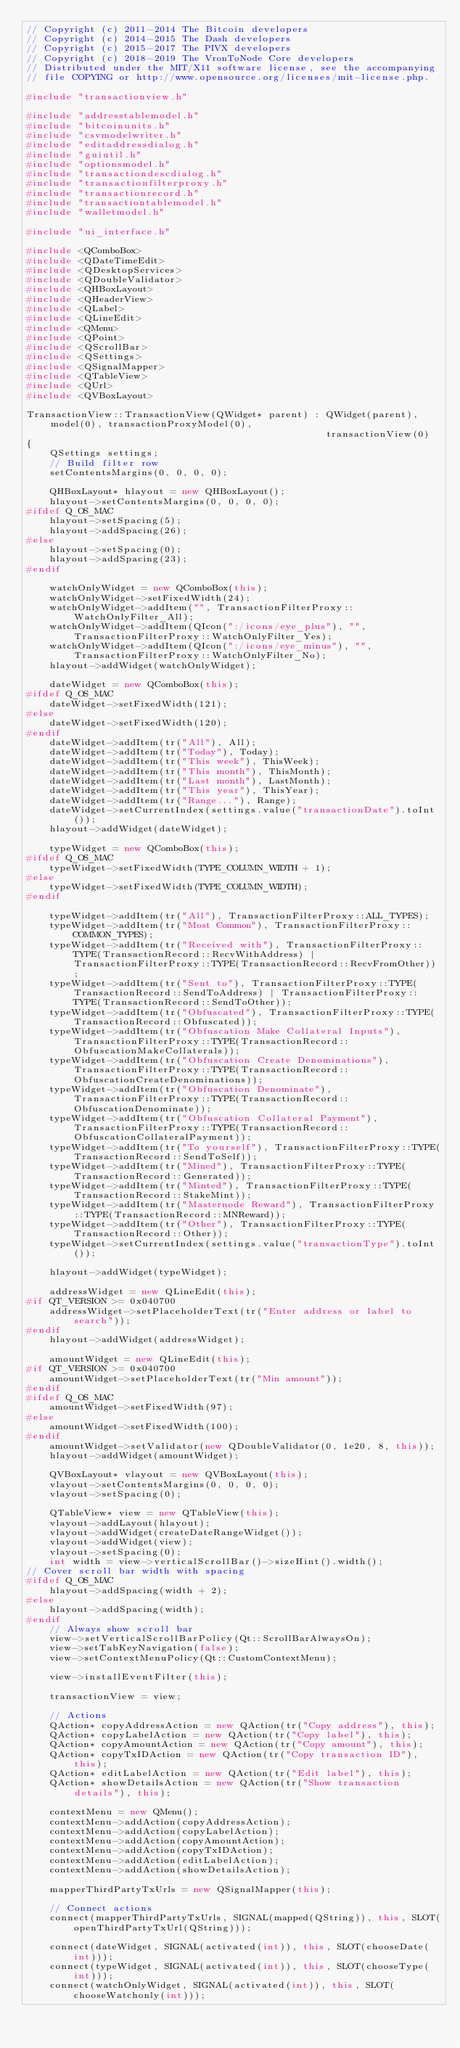Convert code to text. <code><loc_0><loc_0><loc_500><loc_500><_C++_>// Copyright (c) 2011-2014 The Bitcoin developers
// Copyright (c) 2014-2015 The Dash developers
// Copyright (c) 2015-2017 The PIVX developers
// Copyright (c) 2018-2019 The VronToNode Core developers
// Distributed under the MIT/X11 software license, see the accompanying
// file COPYING or http://www.opensource.org/licenses/mit-license.php.

#include "transactionview.h"

#include "addresstablemodel.h"
#include "bitcoinunits.h"
#include "csvmodelwriter.h"
#include "editaddressdialog.h"
#include "guiutil.h"
#include "optionsmodel.h"
#include "transactiondescdialog.h"
#include "transactionfilterproxy.h"
#include "transactionrecord.h"
#include "transactiontablemodel.h"
#include "walletmodel.h"

#include "ui_interface.h"

#include <QComboBox>
#include <QDateTimeEdit>
#include <QDesktopServices>
#include <QDoubleValidator>
#include <QHBoxLayout>
#include <QHeaderView>
#include <QLabel>
#include <QLineEdit>
#include <QMenu>
#include <QPoint>
#include <QScrollBar>
#include <QSettings>
#include <QSignalMapper>
#include <QTableView>
#include <QUrl>
#include <QVBoxLayout>

TransactionView::TransactionView(QWidget* parent) : QWidget(parent), model(0), transactionProxyModel(0),
                                                    transactionView(0)
{
    QSettings settings;
    // Build filter row
    setContentsMargins(0, 0, 0, 0);

    QHBoxLayout* hlayout = new QHBoxLayout();
    hlayout->setContentsMargins(0, 0, 0, 0);
#ifdef Q_OS_MAC
    hlayout->setSpacing(5);
    hlayout->addSpacing(26);
#else
    hlayout->setSpacing(0);
    hlayout->addSpacing(23);
#endif

    watchOnlyWidget = new QComboBox(this);
    watchOnlyWidget->setFixedWidth(24);
    watchOnlyWidget->addItem("", TransactionFilterProxy::WatchOnlyFilter_All);
    watchOnlyWidget->addItem(QIcon(":/icons/eye_plus"), "", TransactionFilterProxy::WatchOnlyFilter_Yes);
    watchOnlyWidget->addItem(QIcon(":/icons/eye_minus"), "", TransactionFilterProxy::WatchOnlyFilter_No);
    hlayout->addWidget(watchOnlyWidget);

    dateWidget = new QComboBox(this);
#ifdef Q_OS_MAC
    dateWidget->setFixedWidth(121);
#else
    dateWidget->setFixedWidth(120);
#endif
    dateWidget->addItem(tr("All"), All);
    dateWidget->addItem(tr("Today"), Today);
    dateWidget->addItem(tr("This week"), ThisWeek);
    dateWidget->addItem(tr("This month"), ThisMonth);
    dateWidget->addItem(tr("Last month"), LastMonth);
    dateWidget->addItem(tr("This year"), ThisYear);
    dateWidget->addItem(tr("Range..."), Range);
    dateWidget->setCurrentIndex(settings.value("transactionDate").toInt());
    hlayout->addWidget(dateWidget);

    typeWidget = new QComboBox(this);
#ifdef Q_OS_MAC
    typeWidget->setFixedWidth(TYPE_COLUMN_WIDTH + 1);
#else
    typeWidget->setFixedWidth(TYPE_COLUMN_WIDTH);
#endif

    typeWidget->addItem(tr("All"), TransactionFilterProxy::ALL_TYPES);
    typeWidget->addItem(tr("Most Common"), TransactionFilterProxy::COMMON_TYPES);
    typeWidget->addItem(tr("Received with"), TransactionFilterProxy::TYPE(TransactionRecord::RecvWithAddress) | TransactionFilterProxy::TYPE(TransactionRecord::RecvFromOther));
    typeWidget->addItem(tr("Sent to"), TransactionFilterProxy::TYPE(TransactionRecord::SendToAddress) | TransactionFilterProxy::TYPE(TransactionRecord::SendToOther));
    typeWidget->addItem(tr("Obfuscated"), TransactionFilterProxy::TYPE(TransactionRecord::Obfuscated));
    typeWidget->addItem(tr("Obfuscation Make Collateral Inputs"), TransactionFilterProxy::TYPE(TransactionRecord::ObfuscationMakeCollaterals));
    typeWidget->addItem(tr("Obfuscation Create Denominations"), TransactionFilterProxy::TYPE(TransactionRecord::ObfuscationCreateDenominations));
    typeWidget->addItem(tr("Obfuscation Denominate"), TransactionFilterProxy::TYPE(TransactionRecord::ObfuscationDenominate));
    typeWidget->addItem(tr("Obfuscation Collateral Payment"), TransactionFilterProxy::TYPE(TransactionRecord::ObfuscationCollateralPayment));
    typeWidget->addItem(tr("To yourself"), TransactionFilterProxy::TYPE(TransactionRecord::SendToSelf));
    typeWidget->addItem(tr("Mined"), TransactionFilterProxy::TYPE(TransactionRecord::Generated));
    typeWidget->addItem(tr("Minted"), TransactionFilterProxy::TYPE(TransactionRecord::StakeMint));
    typeWidget->addItem(tr("Masternode Reward"), TransactionFilterProxy::TYPE(TransactionRecord::MNReward));
    typeWidget->addItem(tr("Other"), TransactionFilterProxy::TYPE(TransactionRecord::Other));
    typeWidget->setCurrentIndex(settings.value("transactionType").toInt());

    hlayout->addWidget(typeWidget);

    addressWidget = new QLineEdit(this);
#if QT_VERSION >= 0x040700
    addressWidget->setPlaceholderText(tr("Enter address or label to search"));
#endif
    hlayout->addWidget(addressWidget);

    amountWidget = new QLineEdit(this);
#if QT_VERSION >= 0x040700
    amountWidget->setPlaceholderText(tr("Min amount"));
#endif
#ifdef Q_OS_MAC
    amountWidget->setFixedWidth(97);
#else
    amountWidget->setFixedWidth(100);
#endif
    amountWidget->setValidator(new QDoubleValidator(0, 1e20, 8, this));
    hlayout->addWidget(amountWidget);

    QVBoxLayout* vlayout = new QVBoxLayout(this);
    vlayout->setContentsMargins(0, 0, 0, 0);
    vlayout->setSpacing(0);

    QTableView* view = new QTableView(this);
    vlayout->addLayout(hlayout);
    vlayout->addWidget(createDateRangeWidget());
    vlayout->addWidget(view);
    vlayout->setSpacing(0);
    int width = view->verticalScrollBar()->sizeHint().width();
// Cover scroll bar width with spacing
#ifdef Q_OS_MAC
    hlayout->addSpacing(width + 2);
#else
    hlayout->addSpacing(width);
#endif
    // Always show scroll bar
    view->setVerticalScrollBarPolicy(Qt::ScrollBarAlwaysOn);
    view->setTabKeyNavigation(false);
    view->setContextMenuPolicy(Qt::CustomContextMenu);

    view->installEventFilter(this);

    transactionView = view;

    // Actions
    QAction* copyAddressAction = new QAction(tr("Copy address"), this);
    QAction* copyLabelAction = new QAction(tr("Copy label"), this);
    QAction* copyAmountAction = new QAction(tr("Copy amount"), this);
    QAction* copyTxIDAction = new QAction(tr("Copy transaction ID"), this);
    QAction* editLabelAction = new QAction(tr("Edit label"), this);
    QAction* showDetailsAction = new QAction(tr("Show transaction details"), this);

    contextMenu = new QMenu();
    contextMenu->addAction(copyAddressAction);
    contextMenu->addAction(copyLabelAction);
    contextMenu->addAction(copyAmountAction);
    contextMenu->addAction(copyTxIDAction);
    contextMenu->addAction(editLabelAction);
    contextMenu->addAction(showDetailsAction);

    mapperThirdPartyTxUrls = new QSignalMapper(this);

    // Connect actions
    connect(mapperThirdPartyTxUrls, SIGNAL(mapped(QString)), this, SLOT(openThirdPartyTxUrl(QString)));

    connect(dateWidget, SIGNAL(activated(int)), this, SLOT(chooseDate(int)));
    connect(typeWidget, SIGNAL(activated(int)), this, SLOT(chooseType(int)));
    connect(watchOnlyWidget, SIGNAL(activated(int)), this, SLOT(chooseWatchonly(int)));</code> 